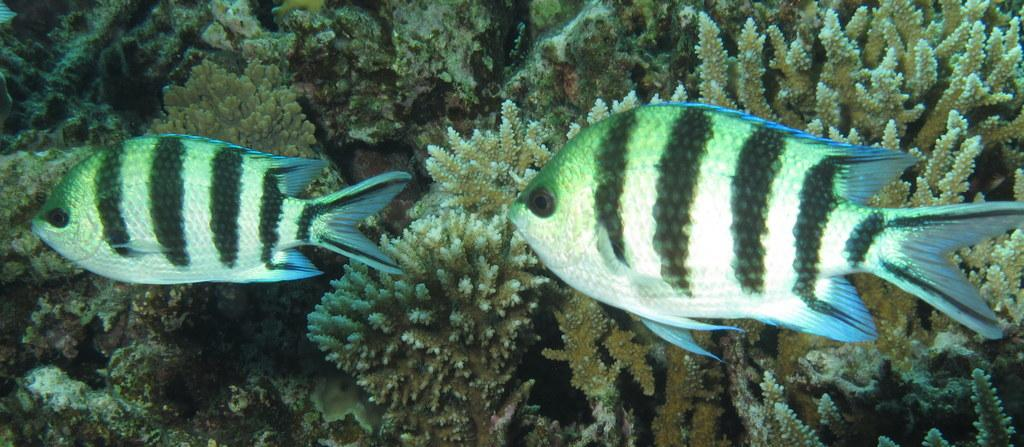What type of animals can be seen in the image? There are fishes in the image. What other elements are present in the image besides the fishes? There are water plants in the image. What is the title of the show featuring the tree in the image? There is no show or tree present in the image; it features fishes and water plants. 